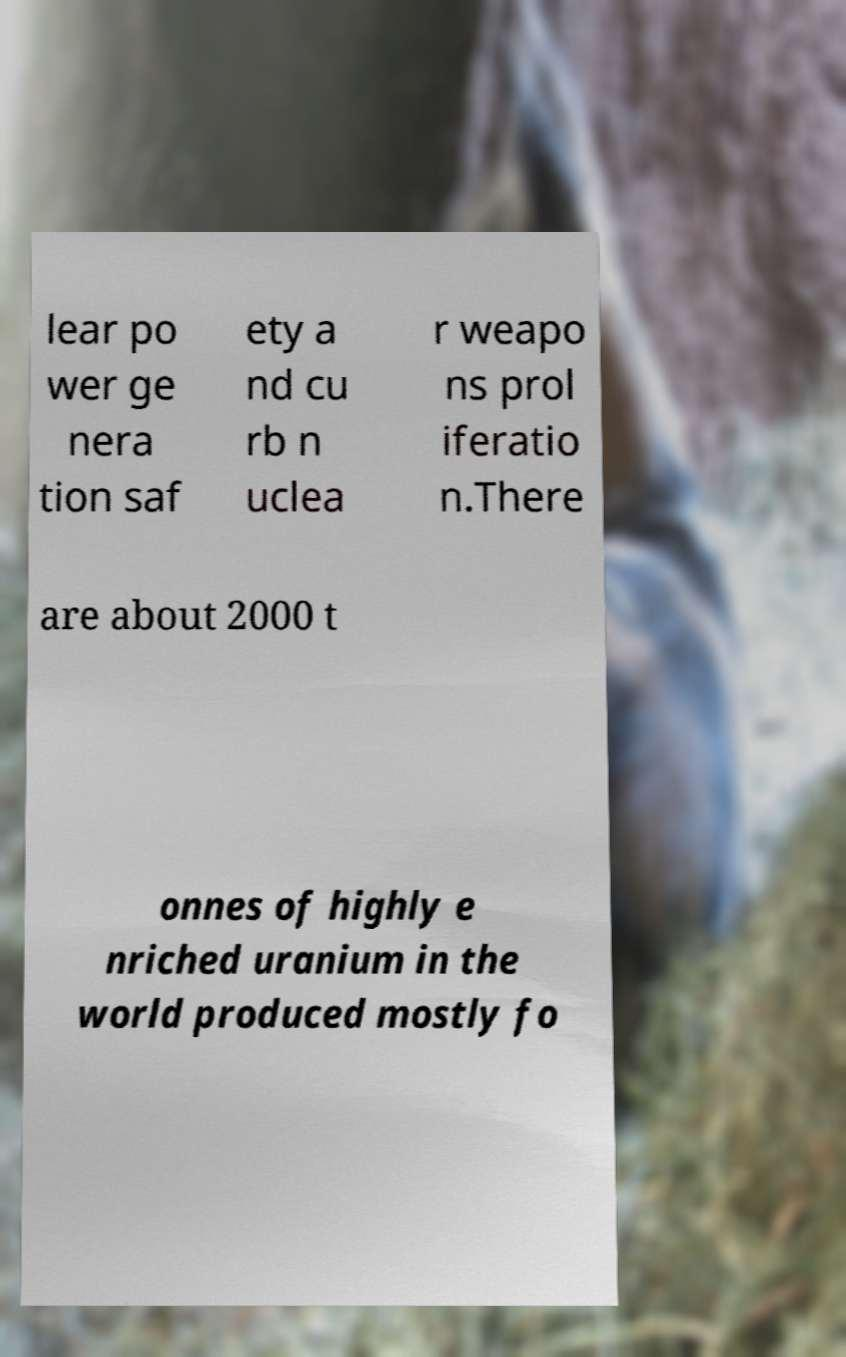For documentation purposes, I need the text within this image transcribed. Could you provide that? lear po wer ge nera tion saf ety a nd cu rb n uclea r weapo ns prol iferatio n.There are about 2000 t onnes of highly e nriched uranium in the world produced mostly fo 